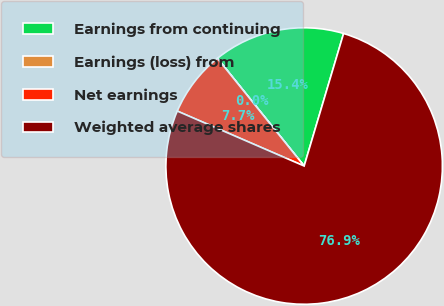Convert chart to OTSL. <chart><loc_0><loc_0><loc_500><loc_500><pie_chart><fcel>Earnings from continuing<fcel>Earnings (loss) from<fcel>Net earnings<fcel>Weighted average shares<nl><fcel>15.39%<fcel>0.01%<fcel>7.7%<fcel>76.9%<nl></chart> 